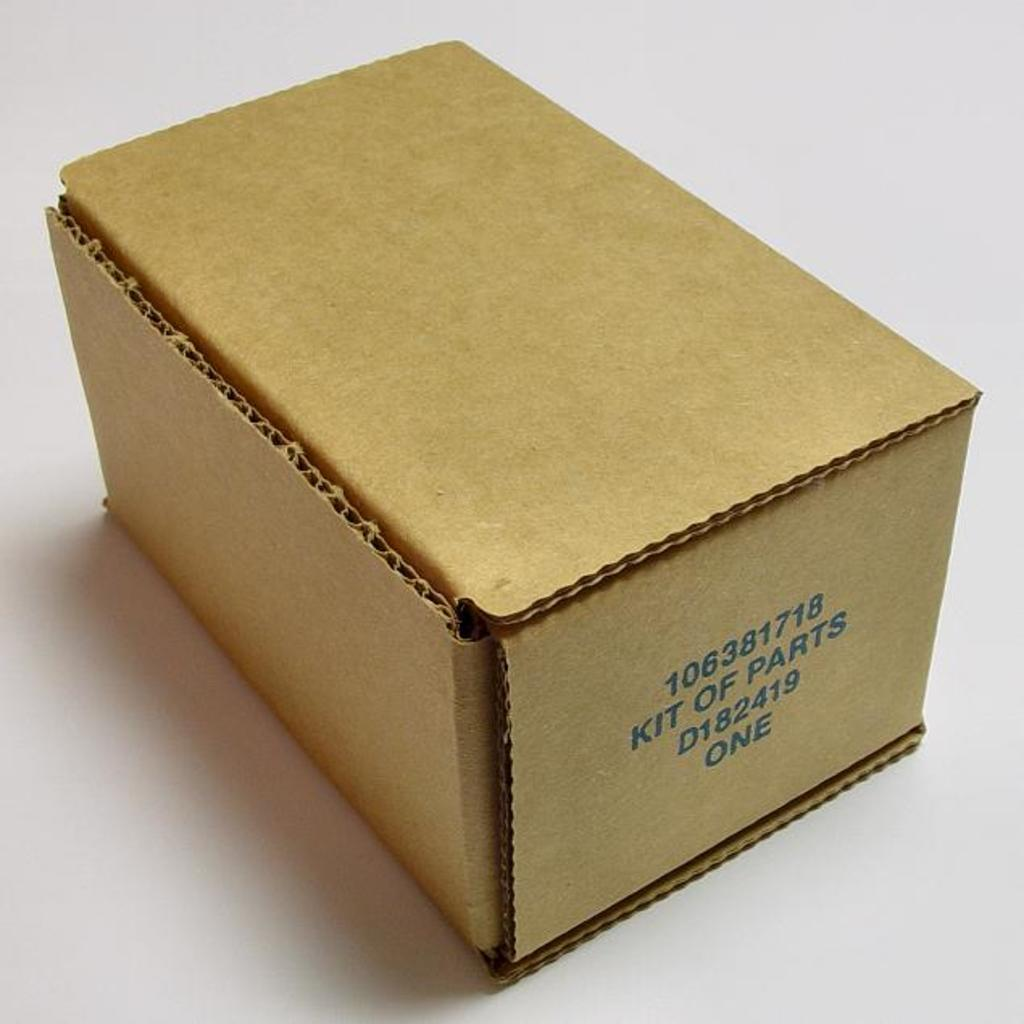Provide a one-sentence caption for the provided image. A cardboard box has the words “kit of parts” on the side. 